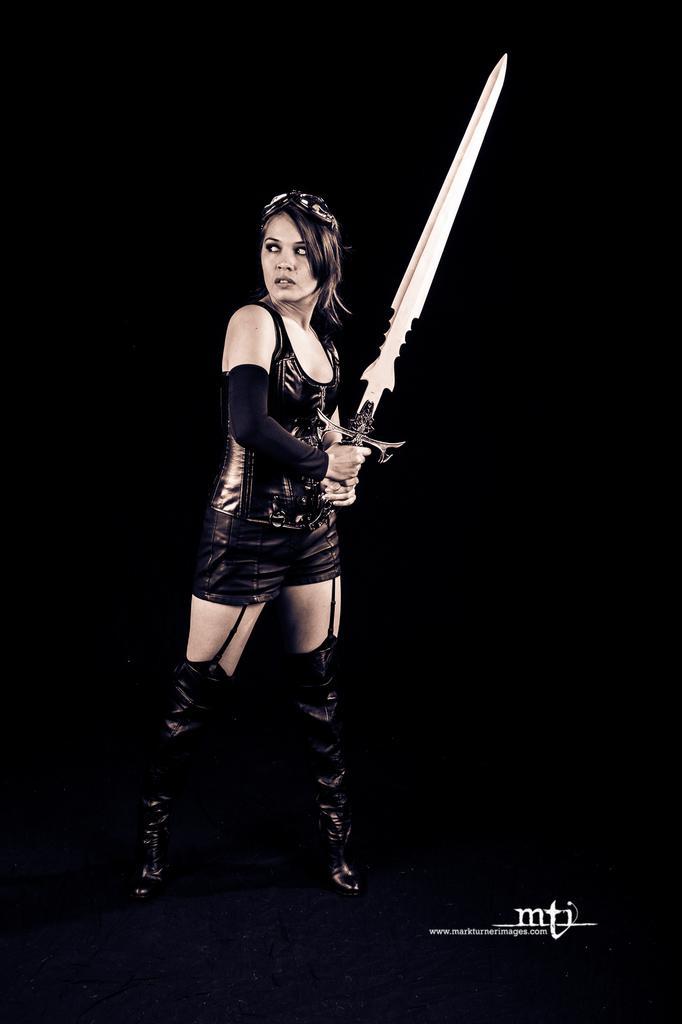Could you give a brief overview of what you see in this image? There is a woman standing and holding a sword. In the background it is dark. In the bottom right side of the image we can see text. 